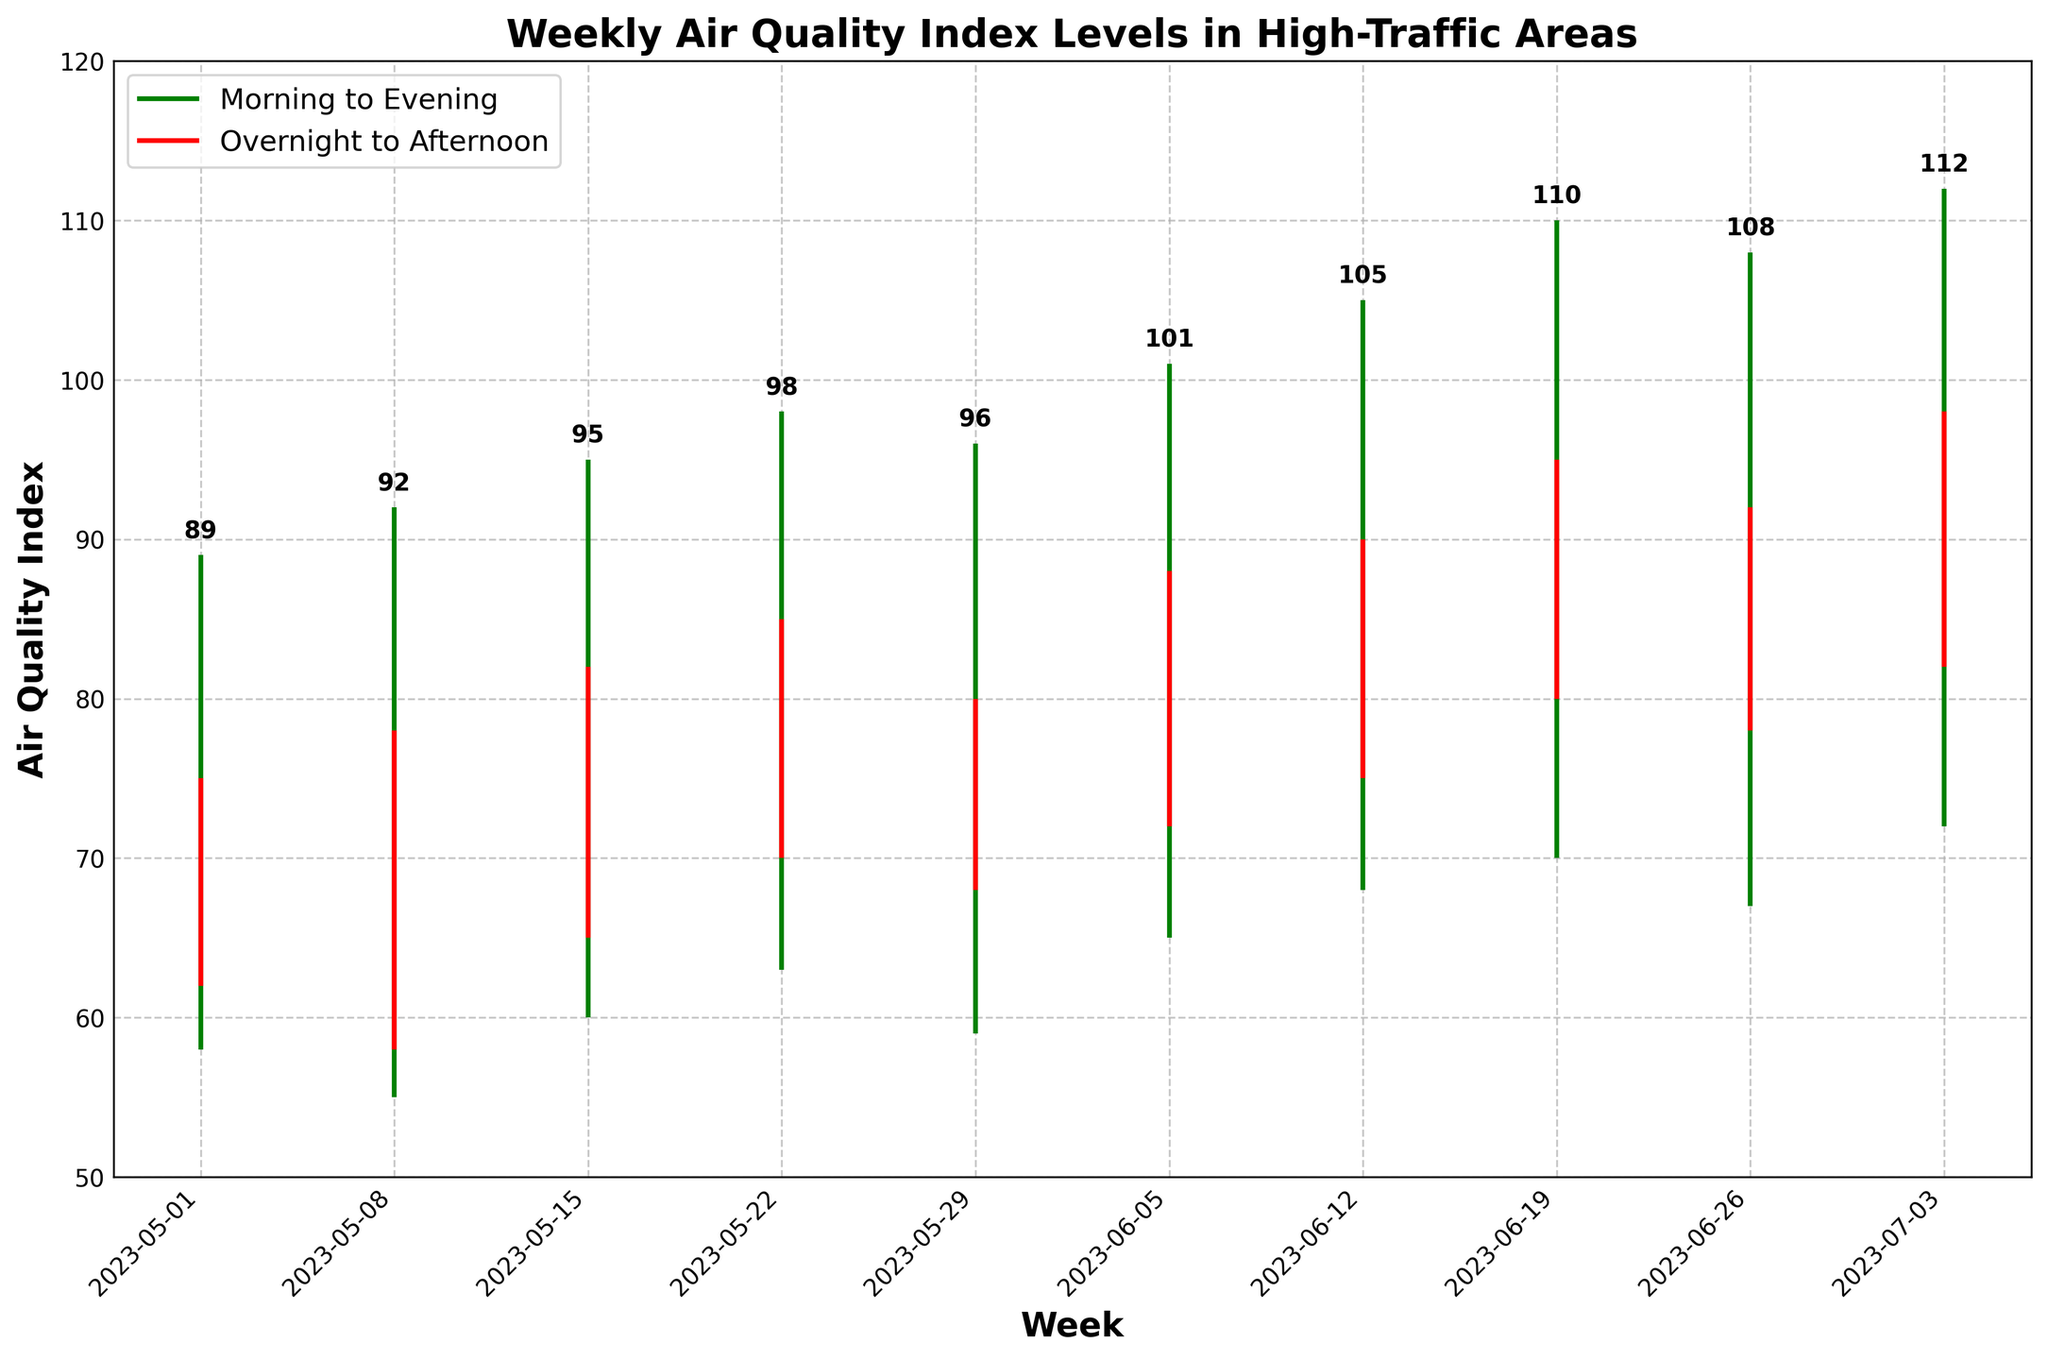What is the title of the figure? The title of the figure is prominently displayed at the top of the plot. It provides a summary of what the chart is depicting.
Answer: Weekly Air Quality Index Levels in High-Traffic Areas On what day does the highest Afternoon air quality index occur? By looking at the annotations or points on the chart, find the day corresponding to the highest Afternoon air quality index.
Answer: 2023-07-03 Which week has the lowest Overnight air quality index? Identify the week where the bottom of the overnight vline is the lowest.
Answer: 2023-05-08 How does the Morning air quality index trend over the weeks? Examine the plot for the Morning values, which are highlighted at the start of each red vline. Identify if these values generally increase, decrease, or stay constant over time.
Answer: Increasing What is the difference between the highest Afternoon and highest Morning air quality index? Find the highest Afternoon value (112 on 2023-07-03) and the highest Morning value (82 on 2023-07-03). Subtract the Morning value from the Afternoon value.
Answer: 30 Which time period generally has the lowest air quality index across all weeks? Compare the general positions of the Morning, Afternoon, Evening, and Overnight values. Determine which period is usually lowest.
Answer: Overnight Between which two weeks is there the largest increase in the Morning air quality index? Identify the weeks and Morning values. Calculate the difference between consecutive weeks, and find the largest positive difference.
Answer: Between 2023-05-22 and 2023-05-29 How does the Overnight air quality index compare to the Morning air quality index on average? Calculate the average values for both the Overnight and Morning periods across all weeks. Compare them to determine which is generally lower.
Answer: Overnight is lower What pattern do you observe in the Afternoon air quality index values? Look at the pattern of the Afternoon air quality index values over the weeks. Identify if there's a trend or pattern.
Answer: Increasing During which week is the Evening air quality index closest to the Morning air quality index? Calculate the difference between the Evening and Morning values for each week. Find the smallest difference.
Answer: 2023-06-26 